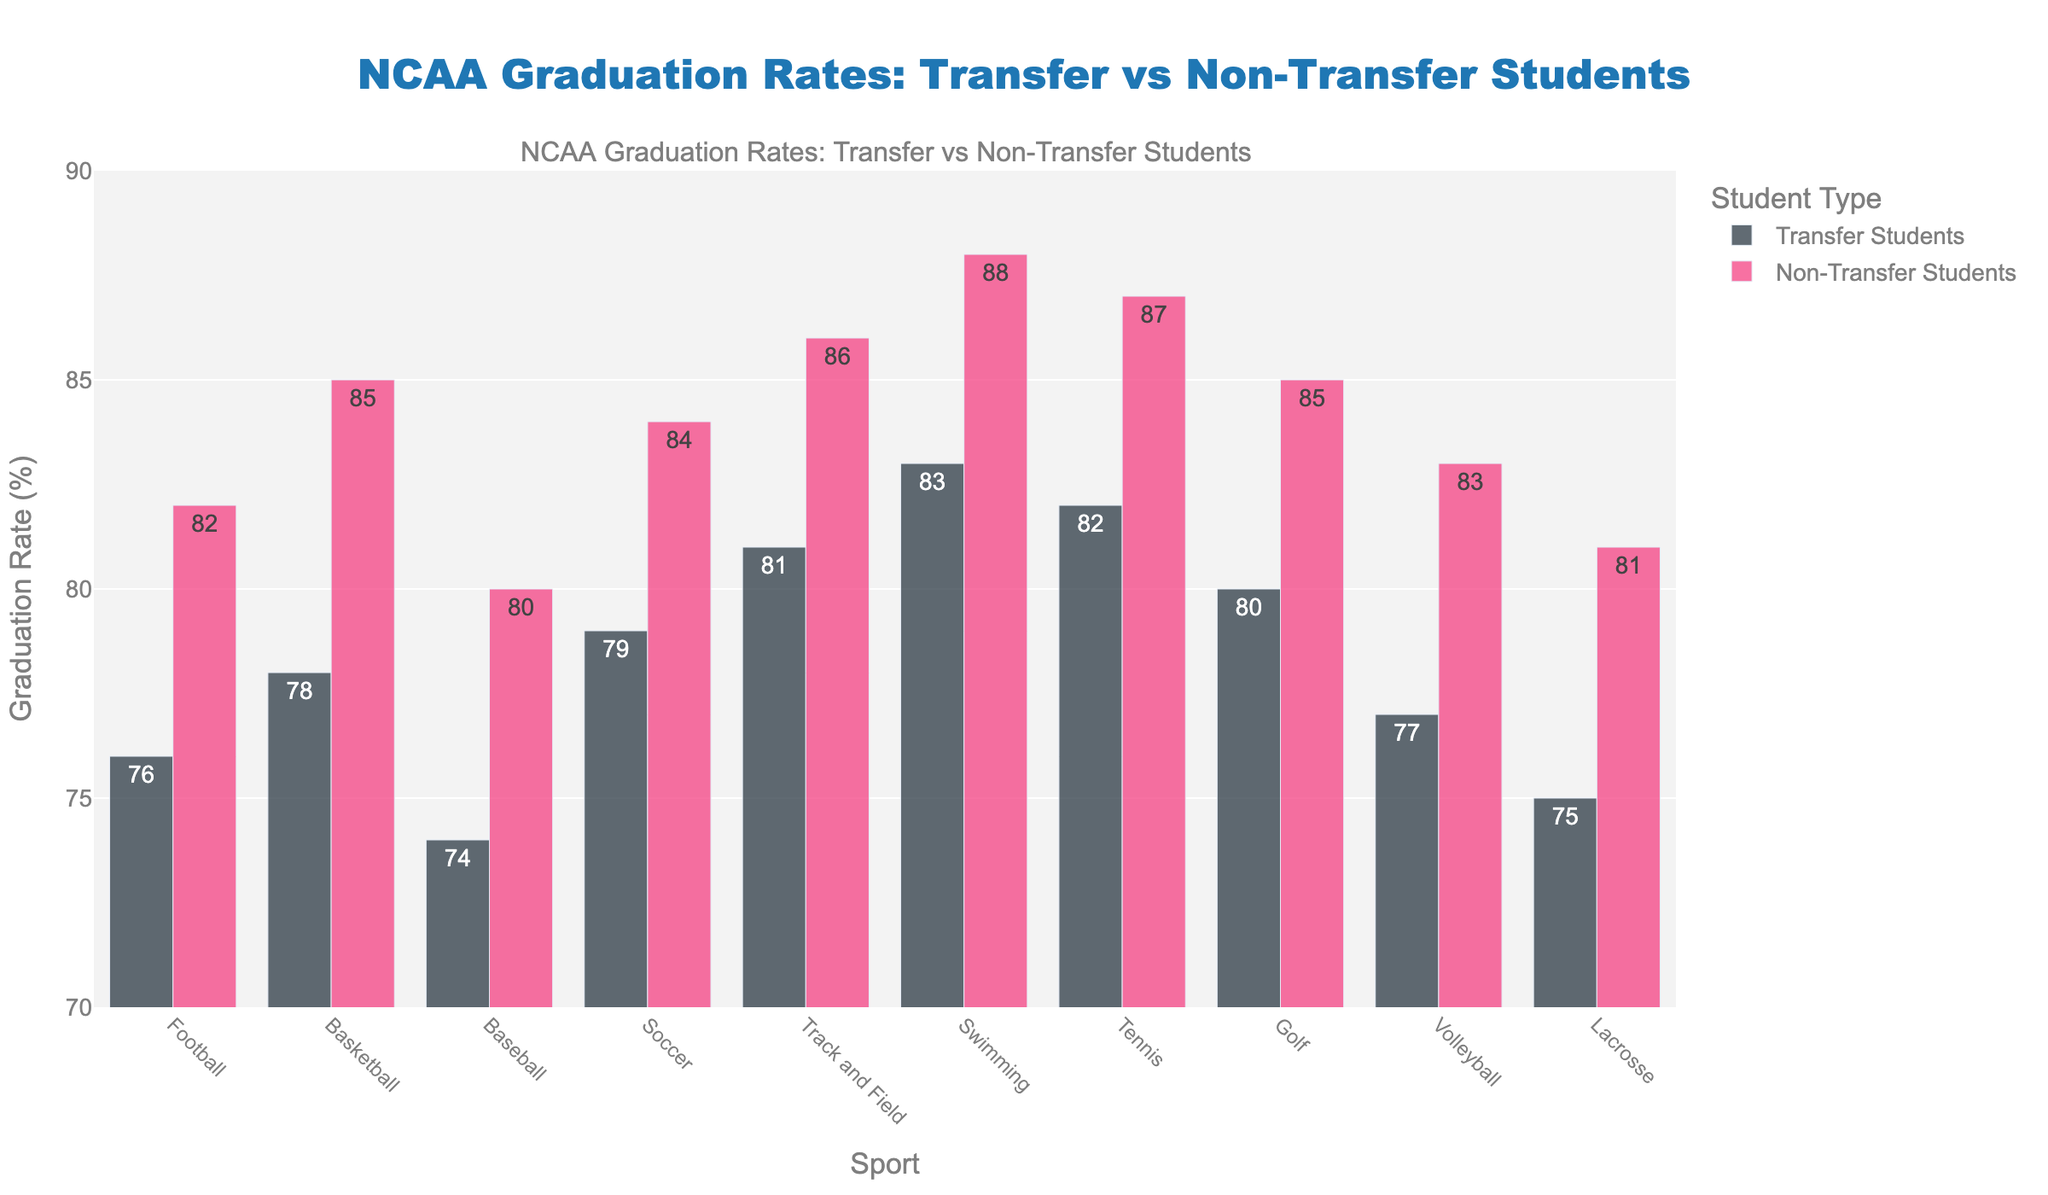Which sport has the highest graduation rate for transfer students? The highest graduation rate for transfer students can be found by scanning the lengths of the corresponding bars in the "Transfer Students" category of the bar chart. Swimming has the highest bar for transfer students with a rate of 83%.
Answer: Swimming Which sport has the smallest difference in graduation rates between transfer and non-transfer students? To find the sport with the smallest difference in graduation rates, calculate the difference for each sport and compare them. For example, Football has a difference of 82 - 76 = 6 percentage points, while Tennis has a difference of 87 - 82 = 5 percentage points. The smallest difference occurs in Tennis, with only 5 percentage points.
Answer: Tennis What's the median graduation rate for non-transfer students? List all the non-transfer students' graduation rates: 82, 85, 80, 84, 86, 88, 87, 85, 83, 81. Arrange them in ascending order: 80, 81, 82, 83, 84, 85, 85, 86, 87, 88. The median (middle value) for this even-numbered list is the average of the 5th and 6th values, so (84 + 85) / 2 = 84.5%.
Answer: 84.5% Which sport shows the largest graduation rate difference favoring non-transfer students? To find this, calculate the difference for each sport where non-transfer students' rate is higher than transfer students'. For example, Soccer has a difference of 84 - 79 = 5 percentage points. Basketball has a difference of 85 - 78 = 7 percentage points, which is larger. The largest difference occurs in Swimming, with a difference of 88 - 83 = 5 percentage points.
Answer: Swimming Which sport has the lowest graduation rate for transfer students? The lowest graduation rate for transfer students can be found by looking at the shortest bar in the "Transfer Students" category. Baseball has the shortest bar with a rate of 74%.
Answer: Baseball How much higher is the graduation rate for non-transfer students in volleyball compared to transfer students? This can be determined by finding the graduation rate difference between non-transfer and transfer students in Volleyball. The non-transfer rate is 83% and the transfer rate is 77%, so the difference is 83 - 77 = 6 percentage points.
Answer: 6 percentage points On average, which group has higher graduation rates across all sports, transfer or non-transfer students? Calculate the average across all sports for both groups. Sum the rates for transfer students: (76 + 78 + 74 + 79 + 81 + 83 + 82 + 80 + 77 + 75) = 785, and divide by the number of sports (10): 785 / 10 = 78.5%. For non-transfer students: (82 + 85 + 80 + 84 + 86 + 88 + 87 + 85 + 83 + 81) = 851, and divide by 10: 851 / 10 = 85.1%. Thus, non-transfer students have a higher average graduation rate.
Answer: Non-transfer students Is there any sport where transfer students have a higher graduation rate than non-transfer students? Look at each pair of bars for the sports to see if the bar for transfer students is higher than that for non-transfer students. None of the bars for transfer students surpass their non-transfer counterparts.
Answer: No What's the combined graduation rate for both transfer and non-transfer students in lacrosse? Add the graduation rates for transfer and non-transfer students in Lacrosse. For transfer students, it is 75%, and for non-transfer students, it is 81%. So, the combined rate is 75 + 81 = 156 percentage points.
Answer: 156 percentage points 